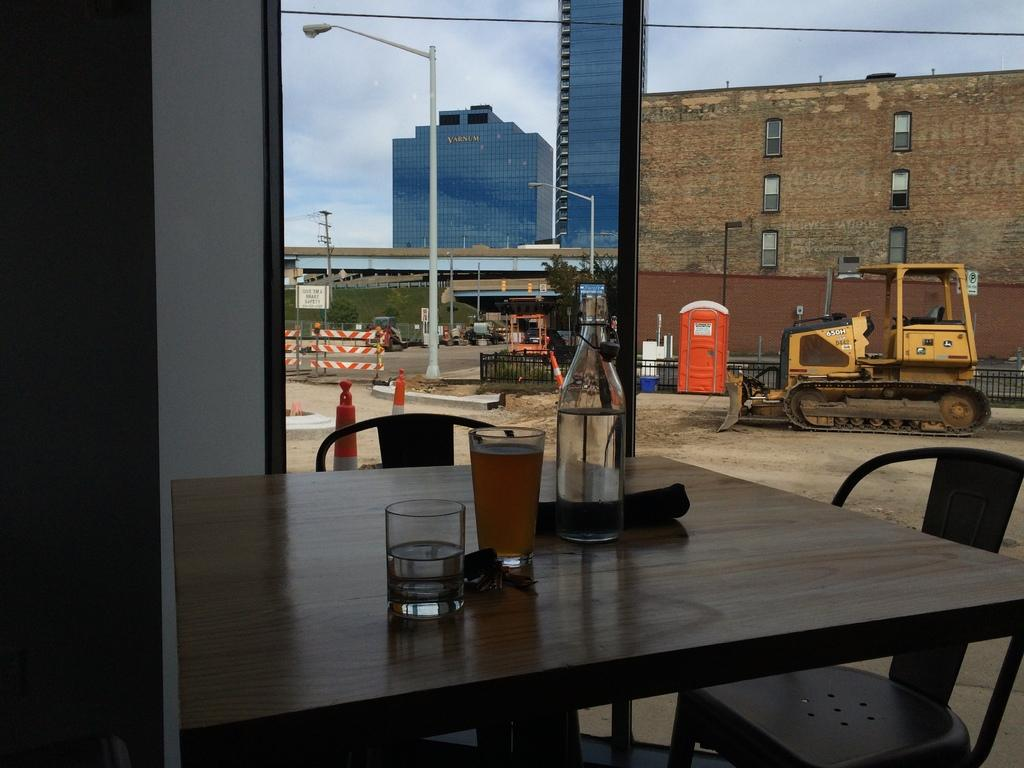What type of furniture is present in the image? There is a table and chairs in the image. What objects can be seen on the table? There are glasses and a bottle on the table. What is the primary feature of the window in the image? There is a glass window in the image. What can be seen through the glass window? Vehicles, a fence, a road, a pole, a light, a building, the sky, and trees can be seen through the glass window. What type of mountain can be seen in the image? There is no mountain present in the image. What kind of ship is visible through the glass window? There is no ship visible through the glass window in the image. 